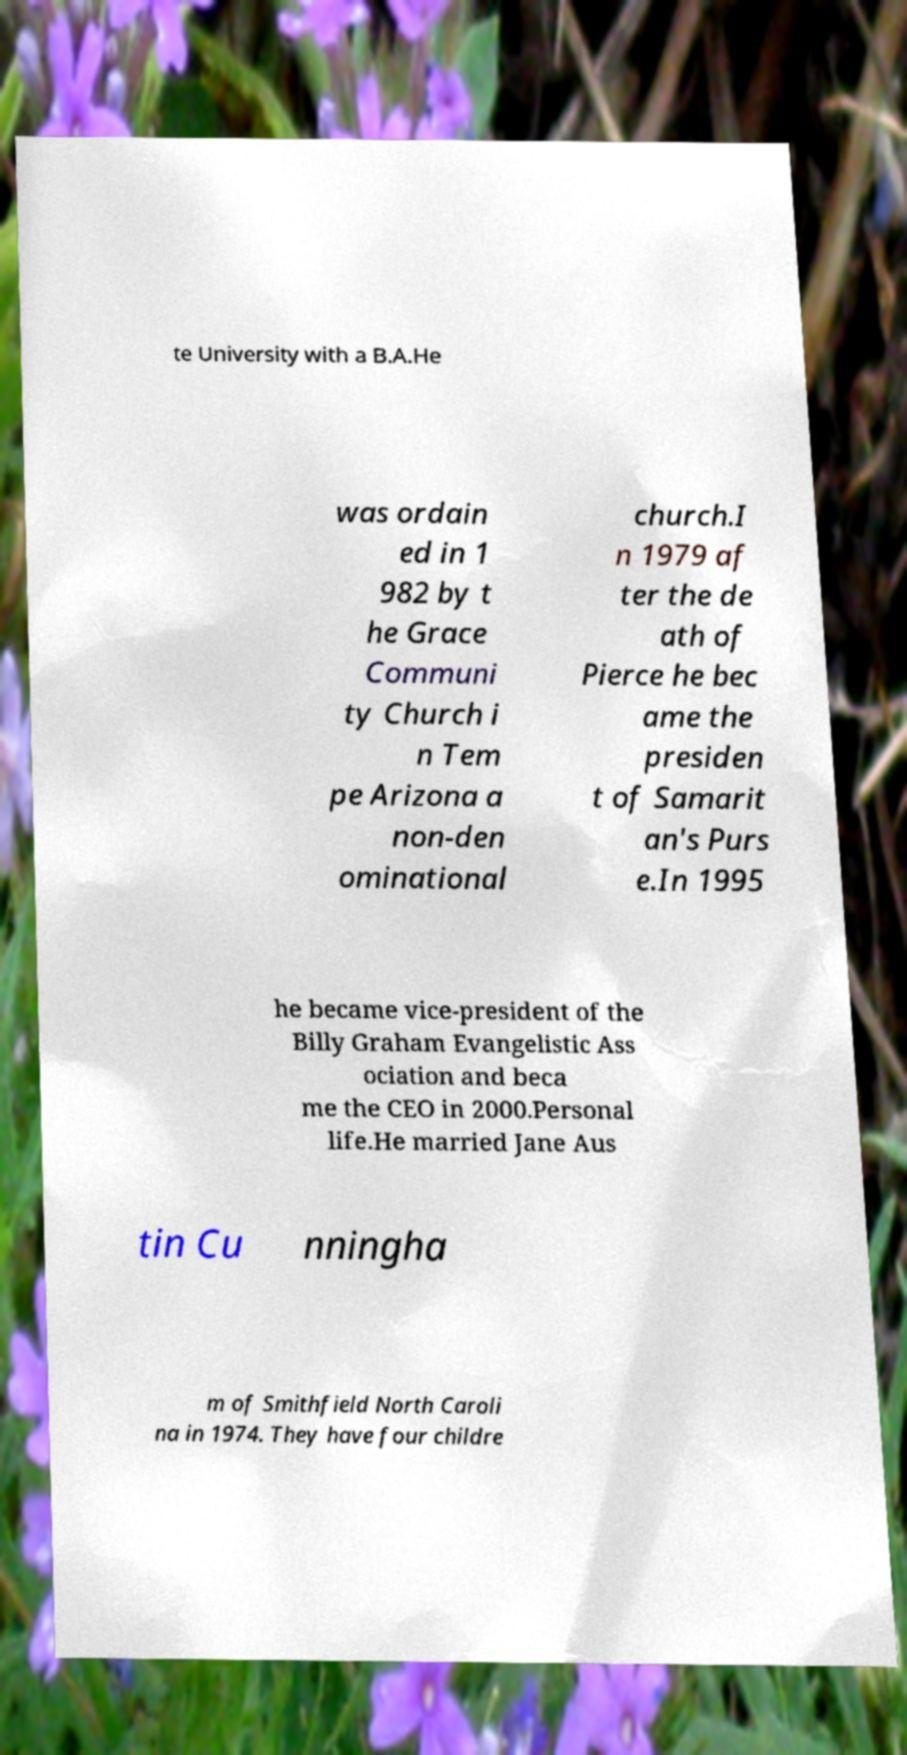I need the written content from this picture converted into text. Can you do that? te University with a B.A.He was ordain ed in 1 982 by t he Grace Communi ty Church i n Tem pe Arizona a non-den ominational church.I n 1979 af ter the de ath of Pierce he bec ame the presiden t of Samarit an's Purs e.In 1995 he became vice-president of the Billy Graham Evangelistic Ass ociation and beca me the CEO in 2000.Personal life.He married Jane Aus tin Cu nningha m of Smithfield North Caroli na in 1974. They have four childre 